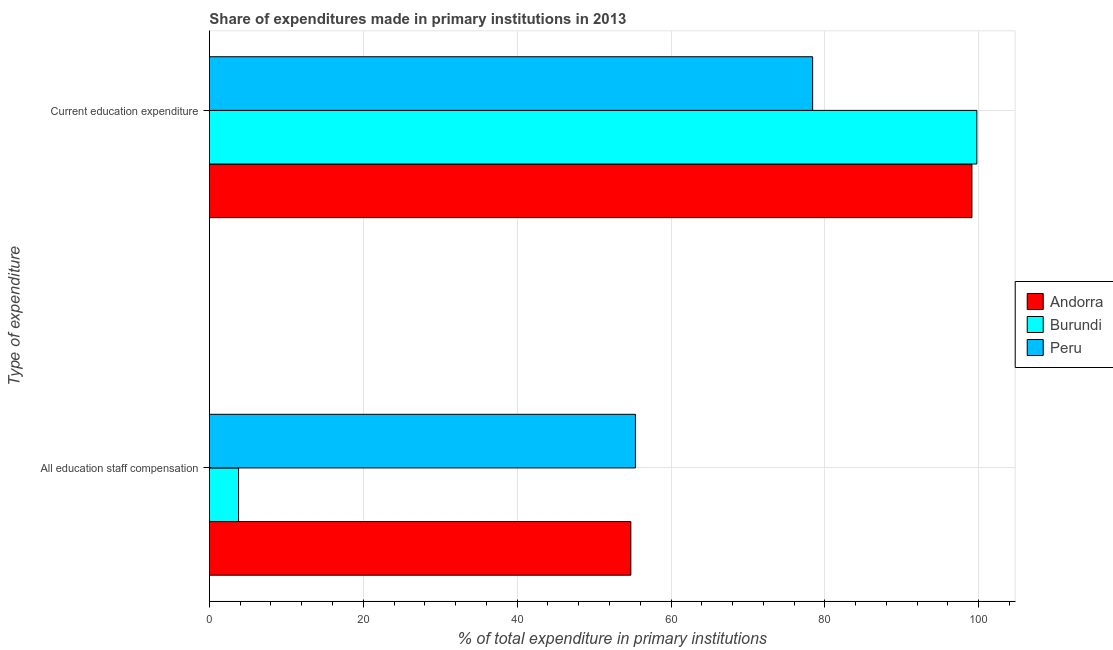How many groups of bars are there?
Make the answer very short. 2. Are the number of bars per tick equal to the number of legend labels?
Ensure brevity in your answer.  Yes. Are the number of bars on each tick of the Y-axis equal?
Give a very brief answer. Yes. How many bars are there on the 1st tick from the top?
Your answer should be very brief. 3. What is the label of the 2nd group of bars from the top?
Offer a terse response. All education staff compensation. What is the expenditure in education in Andorra?
Offer a terse response. 99.12. Across all countries, what is the maximum expenditure in education?
Ensure brevity in your answer.  99.76. Across all countries, what is the minimum expenditure in education?
Ensure brevity in your answer.  78.41. In which country was the expenditure in staff compensation minimum?
Ensure brevity in your answer.  Burundi. What is the total expenditure in staff compensation in the graph?
Offer a very short reply. 113.94. What is the difference between the expenditure in staff compensation in Peru and that in Burundi?
Provide a succinct answer. 51.59. What is the difference between the expenditure in staff compensation in Andorra and the expenditure in education in Peru?
Provide a short and direct response. -23.63. What is the average expenditure in staff compensation per country?
Your answer should be very brief. 37.98. What is the difference between the expenditure in education and expenditure in staff compensation in Peru?
Keep it short and to the point. 23.04. In how many countries, is the expenditure in education greater than 8 %?
Your response must be concise. 3. What is the ratio of the expenditure in education in Burundi to that in Peru?
Give a very brief answer. 1.27. What does the 3rd bar from the top in All education staff compensation represents?
Your answer should be very brief. Andorra. What does the 2nd bar from the bottom in Current education expenditure represents?
Ensure brevity in your answer.  Burundi. How many bars are there?
Offer a very short reply. 6. How many countries are there in the graph?
Your answer should be compact. 3. What is the difference between two consecutive major ticks on the X-axis?
Offer a terse response. 20. Are the values on the major ticks of X-axis written in scientific E-notation?
Offer a very short reply. No. Does the graph contain grids?
Offer a terse response. Yes. How many legend labels are there?
Keep it short and to the point. 3. How are the legend labels stacked?
Make the answer very short. Vertical. What is the title of the graph?
Keep it short and to the point. Share of expenditures made in primary institutions in 2013. Does "High income" appear as one of the legend labels in the graph?
Offer a terse response. No. What is the label or title of the X-axis?
Offer a terse response. % of total expenditure in primary institutions. What is the label or title of the Y-axis?
Your answer should be very brief. Type of expenditure. What is the % of total expenditure in primary institutions of Andorra in All education staff compensation?
Offer a terse response. 54.78. What is the % of total expenditure in primary institutions of Burundi in All education staff compensation?
Ensure brevity in your answer.  3.79. What is the % of total expenditure in primary institutions in Peru in All education staff compensation?
Your response must be concise. 55.38. What is the % of total expenditure in primary institutions of Andorra in Current education expenditure?
Keep it short and to the point. 99.12. What is the % of total expenditure in primary institutions in Burundi in Current education expenditure?
Provide a short and direct response. 99.76. What is the % of total expenditure in primary institutions of Peru in Current education expenditure?
Ensure brevity in your answer.  78.41. Across all Type of expenditure, what is the maximum % of total expenditure in primary institutions of Andorra?
Make the answer very short. 99.12. Across all Type of expenditure, what is the maximum % of total expenditure in primary institutions in Burundi?
Your answer should be compact. 99.76. Across all Type of expenditure, what is the maximum % of total expenditure in primary institutions in Peru?
Keep it short and to the point. 78.41. Across all Type of expenditure, what is the minimum % of total expenditure in primary institutions of Andorra?
Offer a very short reply. 54.78. Across all Type of expenditure, what is the minimum % of total expenditure in primary institutions of Burundi?
Keep it short and to the point. 3.79. Across all Type of expenditure, what is the minimum % of total expenditure in primary institutions in Peru?
Your answer should be very brief. 55.38. What is the total % of total expenditure in primary institutions in Andorra in the graph?
Your response must be concise. 153.9. What is the total % of total expenditure in primary institutions in Burundi in the graph?
Offer a very short reply. 103.54. What is the total % of total expenditure in primary institutions of Peru in the graph?
Offer a very short reply. 133.79. What is the difference between the % of total expenditure in primary institutions of Andorra in All education staff compensation and that in Current education expenditure?
Ensure brevity in your answer.  -44.34. What is the difference between the % of total expenditure in primary institutions of Burundi in All education staff compensation and that in Current education expenditure?
Your answer should be very brief. -95.97. What is the difference between the % of total expenditure in primary institutions in Peru in All education staff compensation and that in Current education expenditure?
Your answer should be very brief. -23.04. What is the difference between the % of total expenditure in primary institutions of Andorra in All education staff compensation and the % of total expenditure in primary institutions of Burundi in Current education expenditure?
Make the answer very short. -44.98. What is the difference between the % of total expenditure in primary institutions of Andorra in All education staff compensation and the % of total expenditure in primary institutions of Peru in Current education expenditure?
Offer a very short reply. -23.63. What is the difference between the % of total expenditure in primary institutions of Burundi in All education staff compensation and the % of total expenditure in primary institutions of Peru in Current education expenditure?
Your answer should be compact. -74.62. What is the average % of total expenditure in primary institutions in Andorra per Type of expenditure?
Your answer should be very brief. 76.95. What is the average % of total expenditure in primary institutions of Burundi per Type of expenditure?
Ensure brevity in your answer.  51.77. What is the average % of total expenditure in primary institutions in Peru per Type of expenditure?
Offer a terse response. 66.89. What is the difference between the % of total expenditure in primary institutions in Andorra and % of total expenditure in primary institutions in Burundi in All education staff compensation?
Provide a short and direct response. 50.99. What is the difference between the % of total expenditure in primary institutions in Andorra and % of total expenditure in primary institutions in Peru in All education staff compensation?
Make the answer very short. -0.6. What is the difference between the % of total expenditure in primary institutions of Burundi and % of total expenditure in primary institutions of Peru in All education staff compensation?
Keep it short and to the point. -51.59. What is the difference between the % of total expenditure in primary institutions in Andorra and % of total expenditure in primary institutions in Burundi in Current education expenditure?
Offer a terse response. -0.64. What is the difference between the % of total expenditure in primary institutions in Andorra and % of total expenditure in primary institutions in Peru in Current education expenditure?
Your response must be concise. 20.71. What is the difference between the % of total expenditure in primary institutions of Burundi and % of total expenditure in primary institutions of Peru in Current education expenditure?
Your response must be concise. 21.34. What is the ratio of the % of total expenditure in primary institutions of Andorra in All education staff compensation to that in Current education expenditure?
Provide a short and direct response. 0.55. What is the ratio of the % of total expenditure in primary institutions of Burundi in All education staff compensation to that in Current education expenditure?
Provide a short and direct response. 0.04. What is the ratio of the % of total expenditure in primary institutions of Peru in All education staff compensation to that in Current education expenditure?
Provide a short and direct response. 0.71. What is the difference between the highest and the second highest % of total expenditure in primary institutions in Andorra?
Your response must be concise. 44.34. What is the difference between the highest and the second highest % of total expenditure in primary institutions in Burundi?
Offer a very short reply. 95.97. What is the difference between the highest and the second highest % of total expenditure in primary institutions of Peru?
Ensure brevity in your answer.  23.04. What is the difference between the highest and the lowest % of total expenditure in primary institutions of Andorra?
Your response must be concise. 44.34. What is the difference between the highest and the lowest % of total expenditure in primary institutions of Burundi?
Provide a succinct answer. 95.97. What is the difference between the highest and the lowest % of total expenditure in primary institutions in Peru?
Offer a terse response. 23.04. 